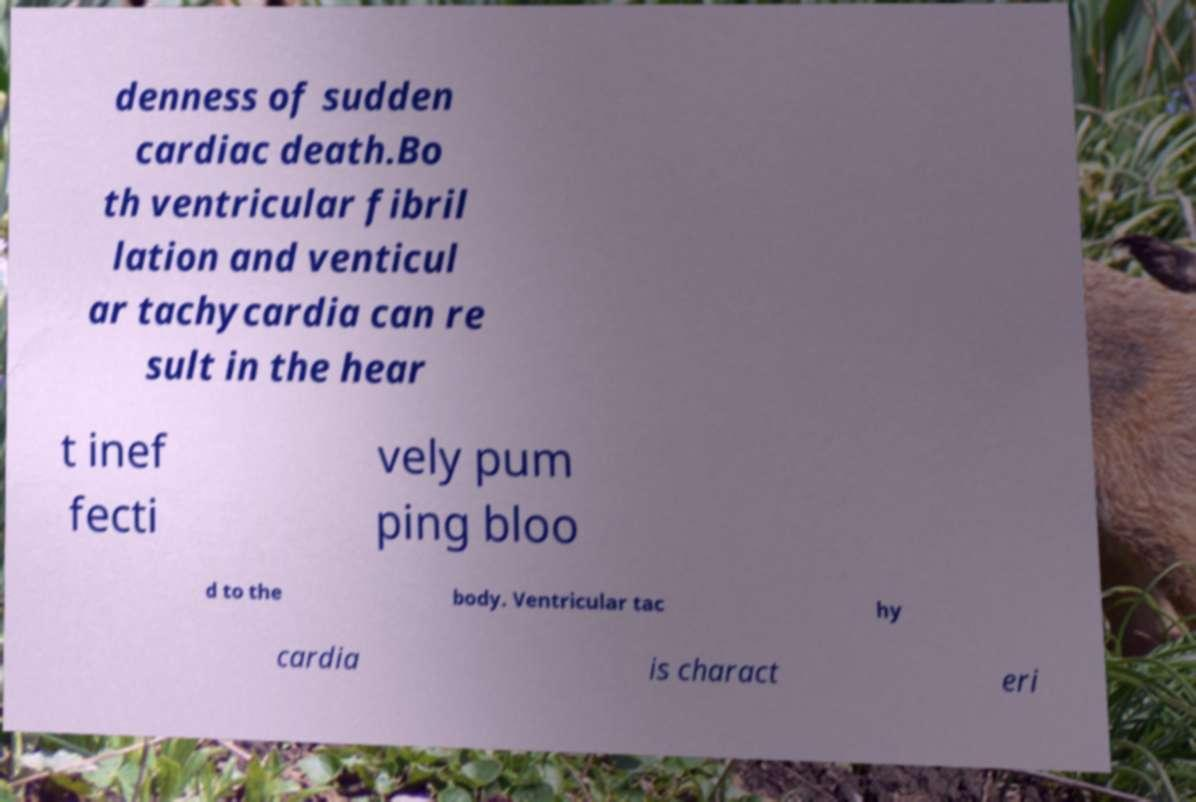Can you read and provide the text displayed in the image?This photo seems to have some interesting text. Can you extract and type it out for me? denness of sudden cardiac death.Bo th ventricular fibril lation and venticul ar tachycardia can re sult in the hear t inef fecti vely pum ping bloo d to the body. Ventricular tac hy cardia is charact eri 